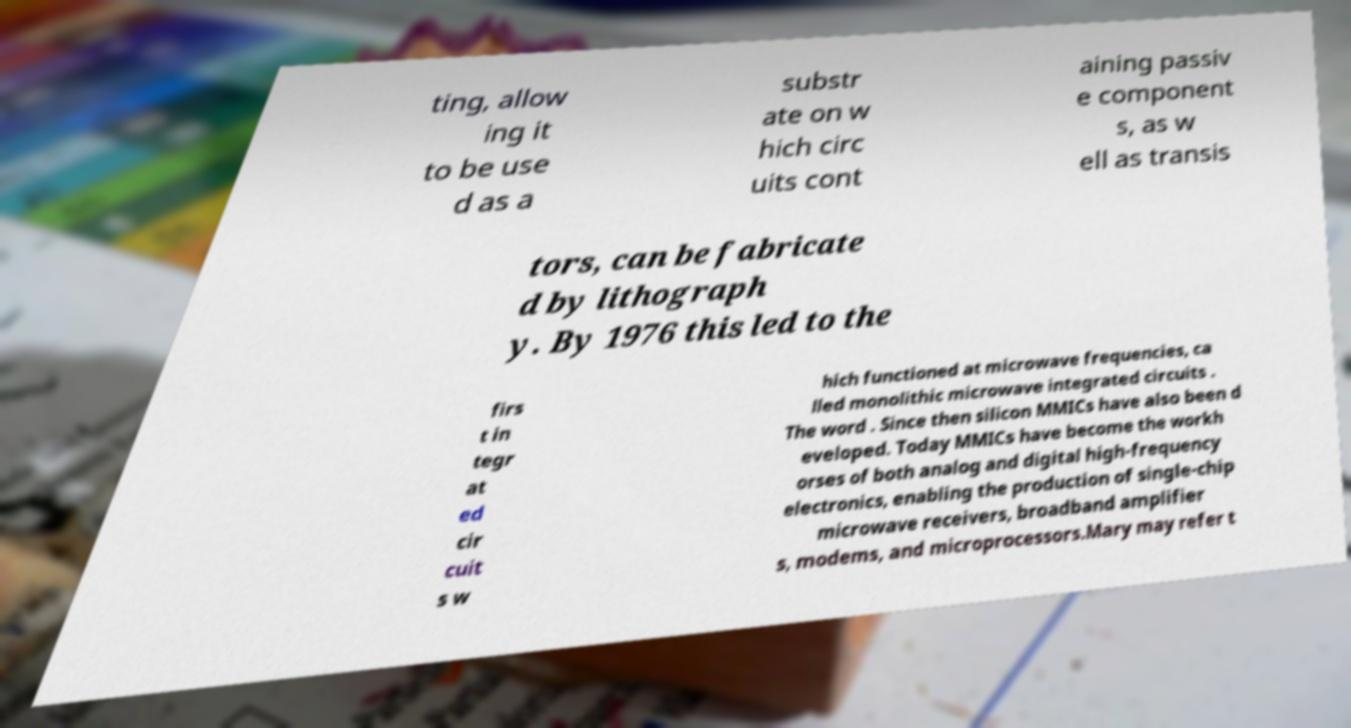I need the written content from this picture converted into text. Can you do that? ting, allow ing it to be use d as a substr ate on w hich circ uits cont aining passiv e component s, as w ell as transis tors, can be fabricate d by lithograph y. By 1976 this led to the firs t in tegr at ed cir cuit s w hich functioned at microwave frequencies, ca lled monolithic microwave integrated circuits . The word . Since then silicon MMICs have also been d eveloped. Today MMICs have become the workh orses of both analog and digital high-frequency electronics, enabling the production of single-chip microwave receivers, broadband amplifier s, modems, and microprocessors.Mary may refer t 